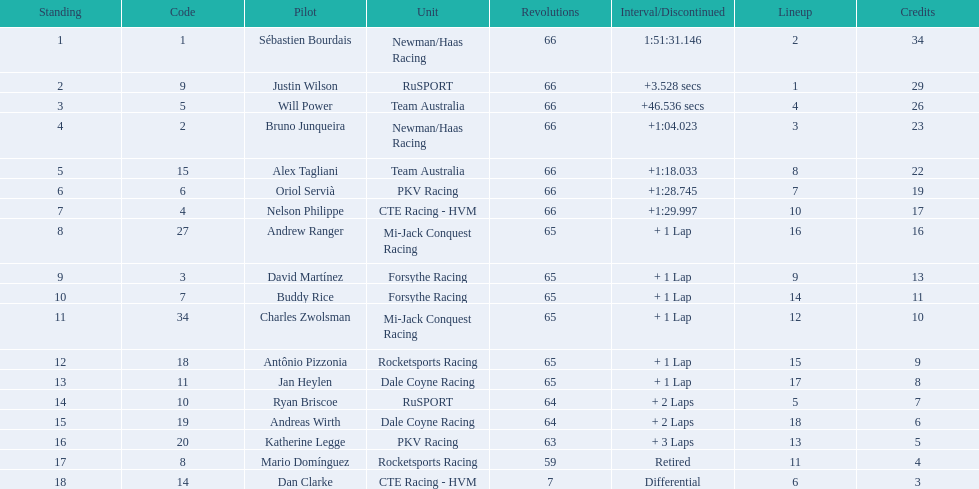How many points did first place receive? 34. How many did last place receive? 3. Who was the recipient of these last place points? Dan Clarke. 